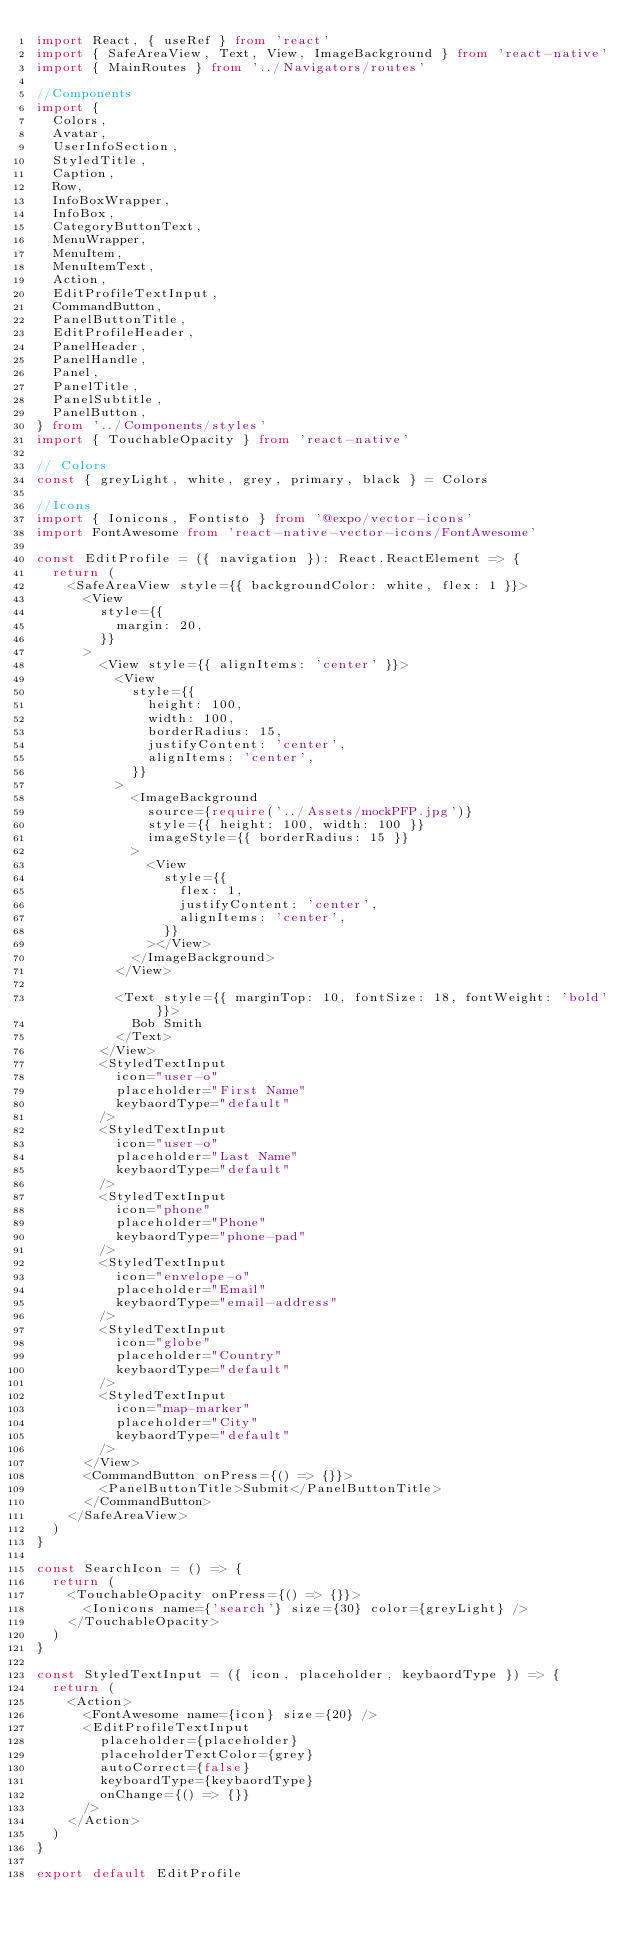<code> <loc_0><loc_0><loc_500><loc_500><_TypeScript_>import React, { useRef } from 'react'
import { SafeAreaView, Text, View, ImageBackground } from 'react-native'
import { MainRoutes } from '../Navigators/routes'

//Components
import {
  Colors,
  Avatar,
  UserInfoSection,
  StyledTitle,
  Caption,
  Row,
  InfoBoxWrapper,
  InfoBox,
  CategoryButtonText,
  MenuWrapper,
  MenuItem,
  MenuItemText,
  Action,
  EditProfileTextInput,
  CommandButton,
  PanelButtonTitle,
  EditProfileHeader,
  PanelHeader,
  PanelHandle,
  Panel,
  PanelTitle,
  PanelSubtitle,
  PanelButton,
} from '../Components/styles'
import { TouchableOpacity } from 'react-native'

// Colors
const { greyLight, white, grey, primary, black } = Colors

//Icons
import { Ionicons, Fontisto } from '@expo/vector-icons'
import FontAwesome from 'react-native-vector-icons/FontAwesome'

const EditProfile = ({ navigation }): React.ReactElement => {
  return (
    <SafeAreaView style={{ backgroundColor: white, flex: 1 }}>
      <View
        style={{
          margin: 20,
        }}
      >
        <View style={{ alignItems: 'center' }}>
          <View
            style={{
              height: 100,
              width: 100,
              borderRadius: 15,
              justifyContent: 'center',
              alignItems: 'center',
            }}
          >
            <ImageBackground
              source={require('../Assets/mockPFP.jpg')}
              style={{ height: 100, width: 100 }}
              imageStyle={{ borderRadius: 15 }}
            >
              <View
                style={{
                  flex: 1,
                  justifyContent: 'center',
                  alignItems: 'center',
                }}
              ></View>
            </ImageBackground>
          </View>

          <Text style={{ marginTop: 10, fontSize: 18, fontWeight: 'bold' }}>
            Bob Smith
          </Text>
        </View>
        <StyledTextInput
          icon="user-o"
          placeholder="First Name"
          keybaordType="default"
        />
        <StyledTextInput
          icon="user-o"
          placeholder="Last Name"
          keybaordType="default"
        />
        <StyledTextInput
          icon="phone"
          placeholder="Phone"
          keybaordType="phone-pad"
        />
        <StyledTextInput
          icon="envelope-o"
          placeholder="Email"
          keybaordType="email-address"
        />
        <StyledTextInput
          icon="globe"
          placeholder="Country"
          keybaordType="default"
        />
        <StyledTextInput
          icon="map-marker"
          placeholder="City"
          keybaordType="default"
        />
      </View>
      <CommandButton onPress={() => {}}>
        <PanelButtonTitle>Submit</PanelButtonTitle>
      </CommandButton>
    </SafeAreaView>
  )
}

const SearchIcon = () => {
  return (
    <TouchableOpacity onPress={() => {}}>
      <Ionicons name={'search'} size={30} color={greyLight} />
    </TouchableOpacity>
  )
}

const StyledTextInput = ({ icon, placeholder, keybaordType }) => {
  return (
    <Action>
      <FontAwesome name={icon} size={20} />
      <EditProfileTextInput
        placeholder={placeholder}
        placeholderTextColor={grey}
        autoCorrect={false}
        keyboardType={keybaordType}
        onChange={() => {}}
      />
    </Action>
  )
}

export default EditProfile
</code> 